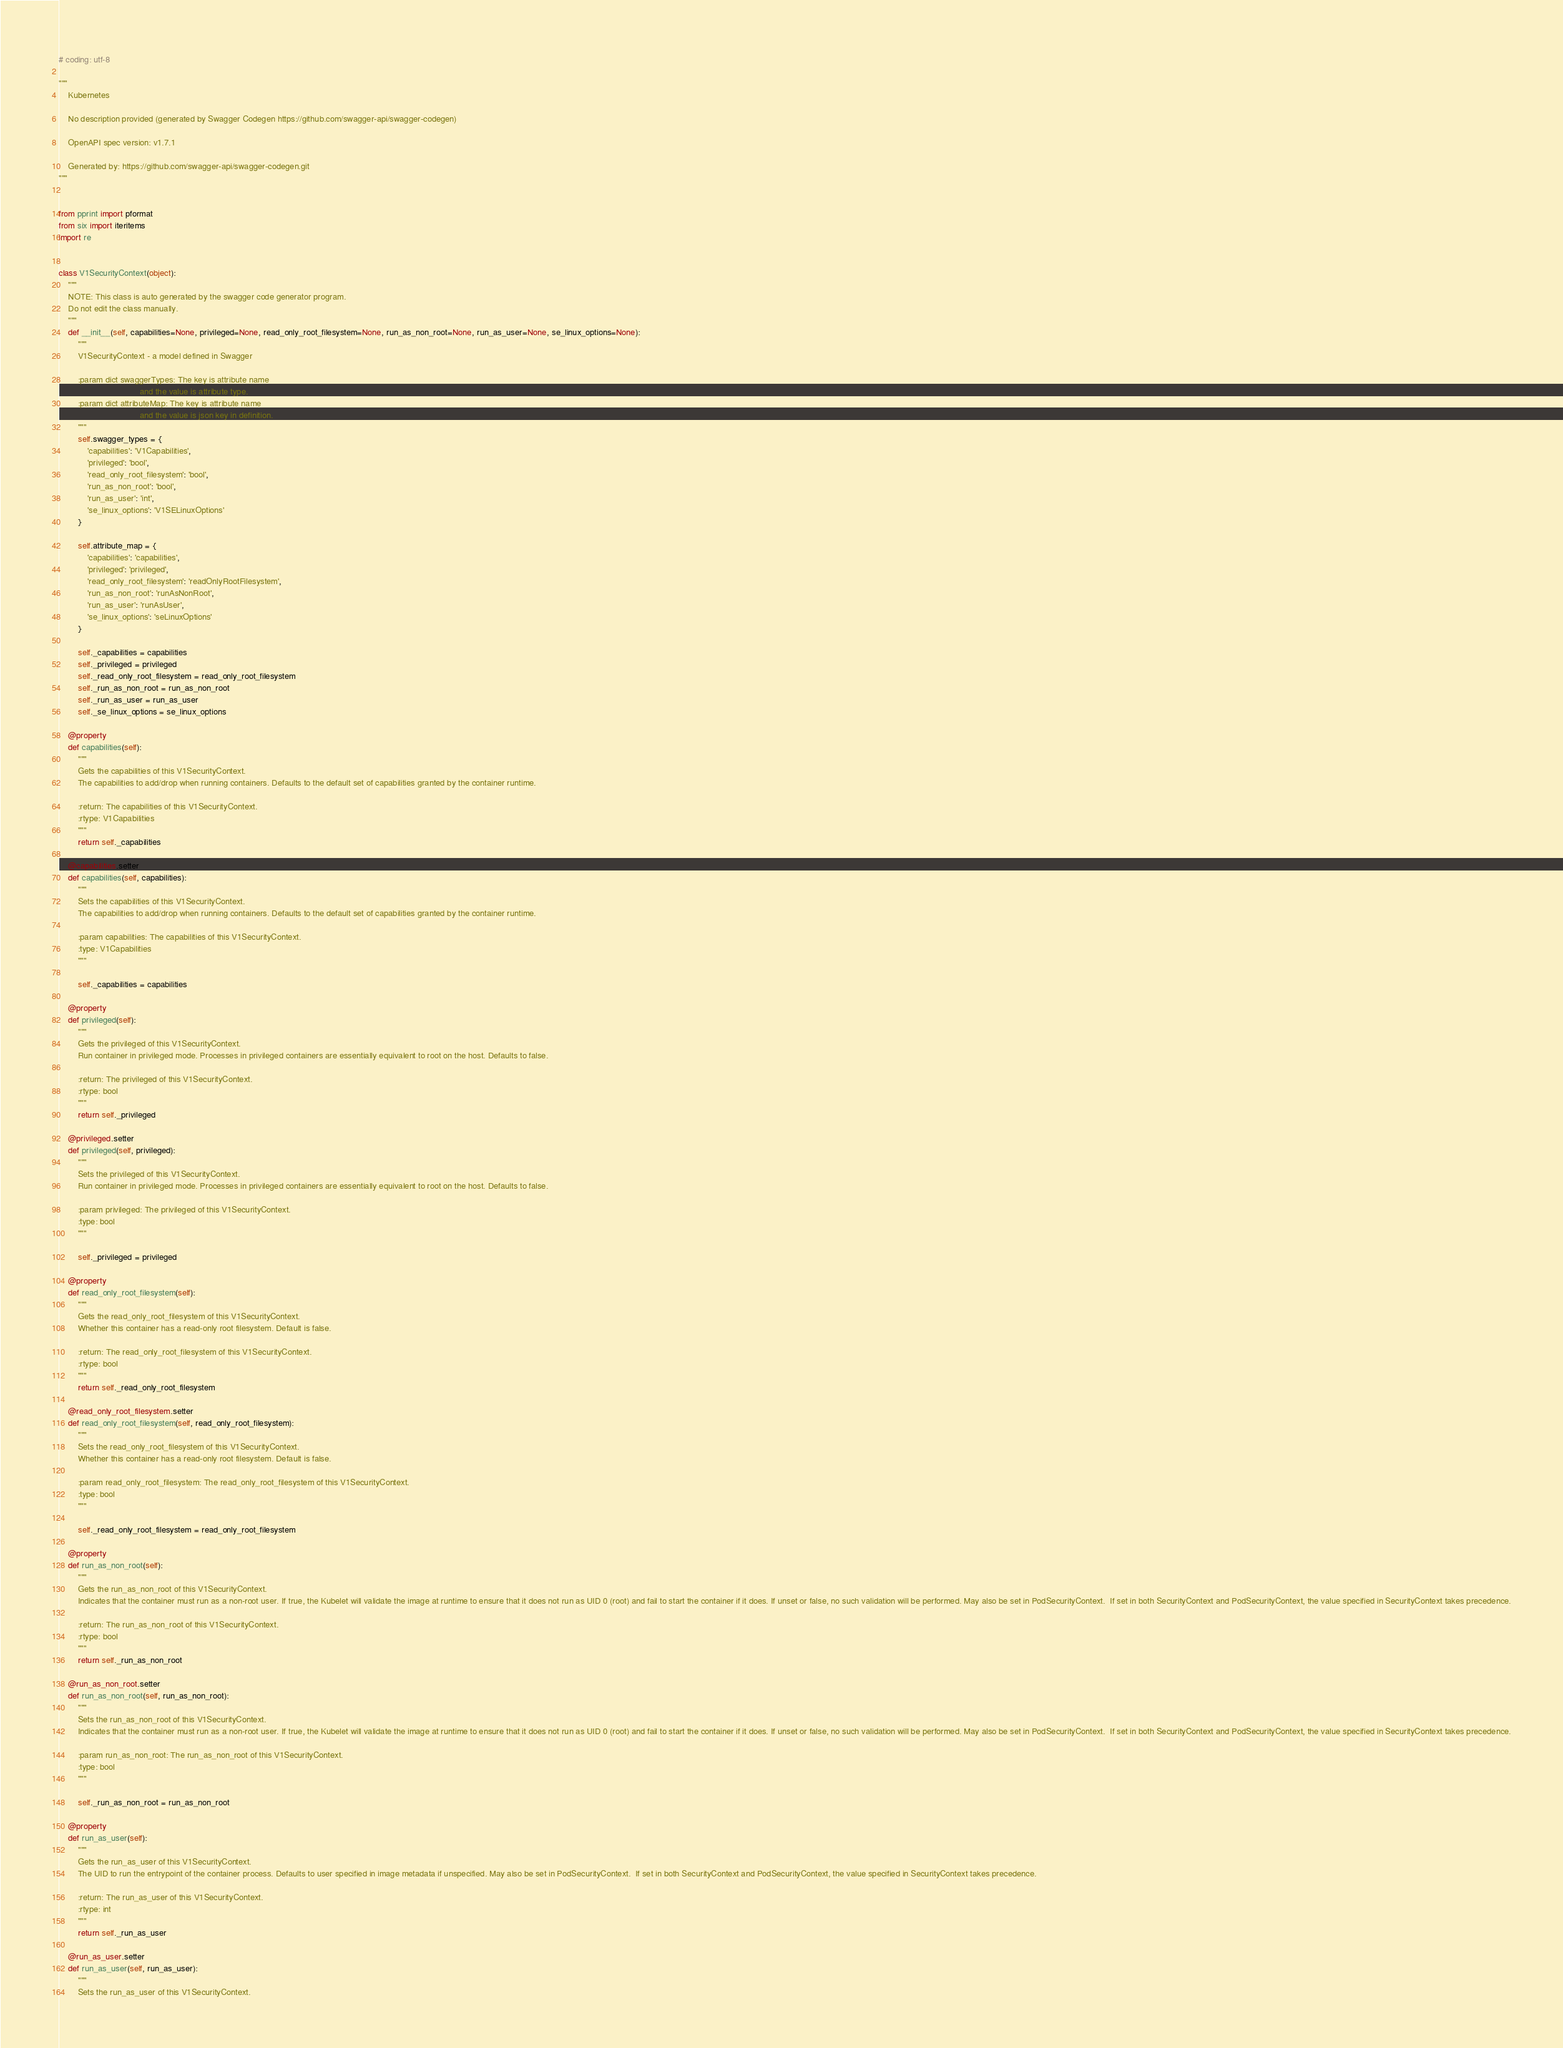Convert code to text. <code><loc_0><loc_0><loc_500><loc_500><_Python_># coding: utf-8

"""
    Kubernetes

    No description provided (generated by Swagger Codegen https://github.com/swagger-api/swagger-codegen)

    OpenAPI spec version: v1.7.1
    
    Generated by: https://github.com/swagger-api/swagger-codegen.git
"""


from pprint import pformat
from six import iteritems
import re


class V1SecurityContext(object):
    """
    NOTE: This class is auto generated by the swagger code generator program.
    Do not edit the class manually.
    """
    def __init__(self, capabilities=None, privileged=None, read_only_root_filesystem=None, run_as_non_root=None, run_as_user=None, se_linux_options=None):
        """
        V1SecurityContext - a model defined in Swagger

        :param dict swaggerTypes: The key is attribute name
                                  and the value is attribute type.
        :param dict attributeMap: The key is attribute name
                                  and the value is json key in definition.
        """
        self.swagger_types = {
            'capabilities': 'V1Capabilities',
            'privileged': 'bool',
            'read_only_root_filesystem': 'bool',
            'run_as_non_root': 'bool',
            'run_as_user': 'int',
            'se_linux_options': 'V1SELinuxOptions'
        }

        self.attribute_map = {
            'capabilities': 'capabilities',
            'privileged': 'privileged',
            'read_only_root_filesystem': 'readOnlyRootFilesystem',
            'run_as_non_root': 'runAsNonRoot',
            'run_as_user': 'runAsUser',
            'se_linux_options': 'seLinuxOptions'
        }

        self._capabilities = capabilities
        self._privileged = privileged
        self._read_only_root_filesystem = read_only_root_filesystem
        self._run_as_non_root = run_as_non_root
        self._run_as_user = run_as_user
        self._se_linux_options = se_linux_options

    @property
    def capabilities(self):
        """
        Gets the capabilities of this V1SecurityContext.
        The capabilities to add/drop when running containers. Defaults to the default set of capabilities granted by the container runtime.

        :return: The capabilities of this V1SecurityContext.
        :rtype: V1Capabilities
        """
        return self._capabilities

    @capabilities.setter
    def capabilities(self, capabilities):
        """
        Sets the capabilities of this V1SecurityContext.
        The capabilities to add/drop when running containers. Defaults to the default set of capabilities granted by the container runtime.

        :param capabilities: The capabilities of this V1SecurityContext.
        :type: V1Capabilities
        """

        self._capabilities = capabilities

    @property
    def privileged(self):
        """
        Gets the privileged of this V1SecurityContext.
        Run container in privileged mode. Processes in privileged containers are essentially equivalent to root on the host. Defaults to false.

        :return: The privileged of this V1SecurityContext.
        :rtype: bool
        """
        return self._privileged

    @privileged.setter
    def privileged(self, privileged):
        """
        Sets the privileged of this V1SecurityContext.
        Run container in privileged mode. Processes in privileged containers are essentially equivalent to root on the host. Defaults to false.

        :param privileged: The privileged of this V1SecurityContext.
        :type: bool
        """

        self._privileged = privileged

    @property
    def read_only_root_filesystem(self):
        """
        Gets the read_only_root_filesystem of this V1SecurityContext.
        Whether this container has a read-only root filesystem. Default is false.

        :return: The read_only_root_filesystem of this V1SecurityContext.
        :rtype: bool
        """
        return self._read_only_root_filesystem

    @read_only_root_filesystem.setter
    def read_only_root_filesystem(self, read_only_root_filesystem):
        """
        Sets the read_only_root_filesystem of this V1SecurityContext.
        Whether this container has a read-only root filesystem. Default is false.

        :param read_only_root_filesystem: The read_only_root_filesystem of this V1SecurityContext.
        :type: bool
        """

        self._read_only_root_filesystem = read_only_root_filesystem

    @property
    def run_as_non_root(self):
        """
        Gets the run_as_non_root of this V1SecurityContext.
        Indicates that the container must run as a non-root user. If true, the Kubelet will validate the image at runtime to ensure that it does not run as UID 0 (root) and fail to start the container if it does. If unset or false, no such validation will be performed. May also be set in PodSecurityContext.  If set in both SecurityContext and PodSecurityContext, the value specified in SecurityContext takes precedence.

        :return: The run_as_non_root of this V1SecurityContext.
        :rtype: bool
        """
        return self._run_as_non_root

    @run_as_non_root.setter
    def run_as_non_root(self, run_as_non_root):
        """
        Sets the run_as_non_root of this V1SecurityContext.
        Indicates that the container must run as a non-root user. If true, the Kubelet will validate the image at runtime to ensure that it does not run as UID 0 (root) and fail to start the container if it does. If unset or false, no such validation will be performed. May also be set in PodSecurityContext.  If set in both SecurityContext and PodSecurityContext, the value specified in SecurityContext takes precedence.

        :param run_as_non_root: The run_as_non_root of this V1SecurityContext.
        :type: bool
        """

        self._run_as_non_root = run_as_non_root

    @property
    def run_as_user(self):
        """
        Gets the run_as_user of this V1SecurityContext.
        The UID to run the entrypoint of the container process. Defaults to user specified in image metadata if unspecified. May also be set in PodSecurityContext.  If set in both SecurityContext and PodSecurityContext, the value specified in SecurityContext takes precedence.

        :return: The run_as_user of this V1SecurityContext.
        :rtype: int
        """
        return self._run_as_user

    @run_as_user.setter
    def run_as_user(self, run_as_user):
        """
        Sets the run_as_user of this V1SecurityContext.</code> 